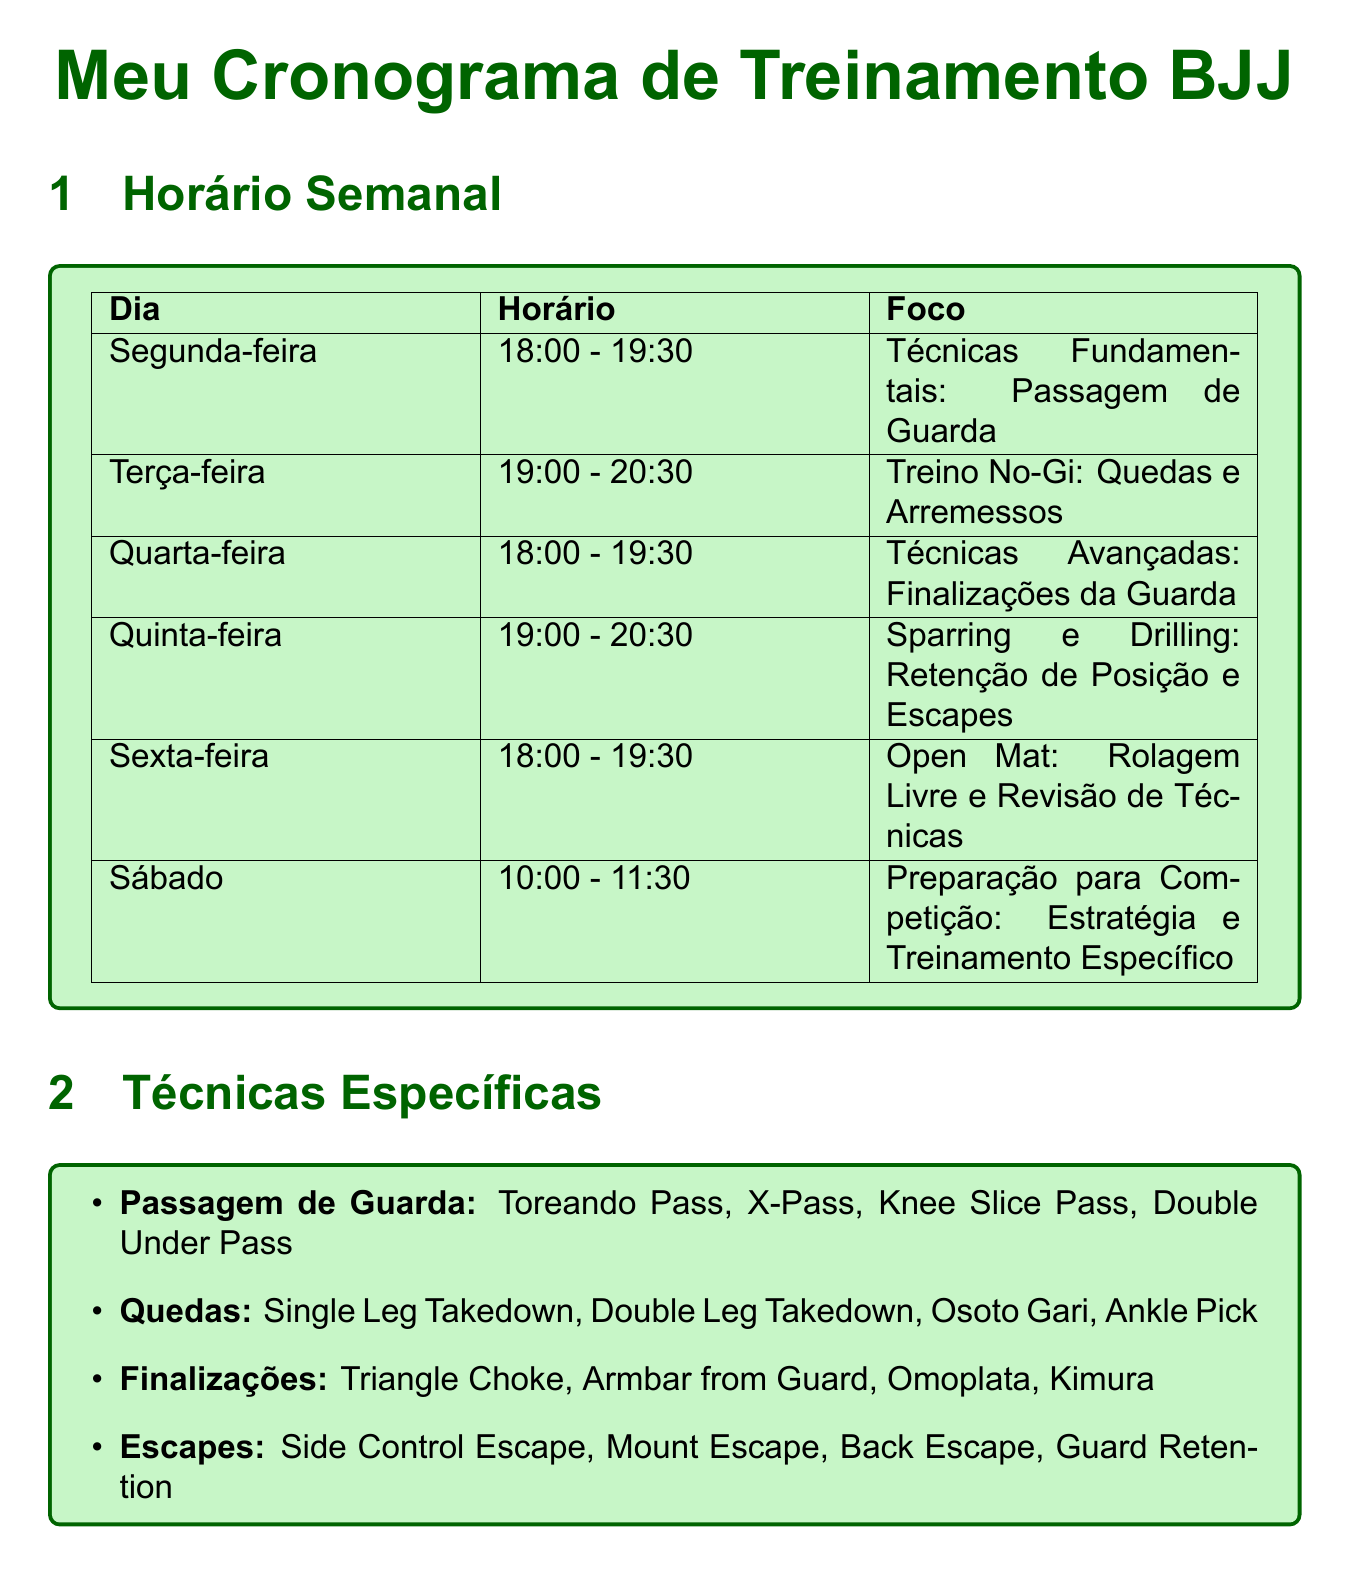What is the focus for the Monday class? The focus for the Monday class is specified in the schedule as "Guard Passing."
Answer: Guard Passing What time does the No-Gi Training class start on Tuesday? The class time is listed as starting at "19:00."
Answer: 19:00 Which instructor leads Academia Gracie Barra? The document states that João Silva is the head instructor for Academia Gracie Barra.
Answer: João Silva What is the registration deadline for the Copa Rio International de Jiu-Jitsu? The deadline is mentioned as "July 20, 2023."
Answer: July 20, 2023 How many specific techniques are listed under Guard Passing? The document lists four techniques under the Guard Passing category.
Answer: Four What class type is focused on Sparring and Drilling? The schedule specifies that Sparring and Drilling focuses on "Position Retention and Escapes."
Answer: Position Retention and Escapes What is the time for the Saturday Competition Preparation class? The time is listed as "10:00 - 11:30."
Answer: 10:00 - 11:30 Where is Team Nogueira BJJ located? The location specified for Team Nogueira BJJ is "Avenida Central, 456."
Answer: Avenida Central, 456 